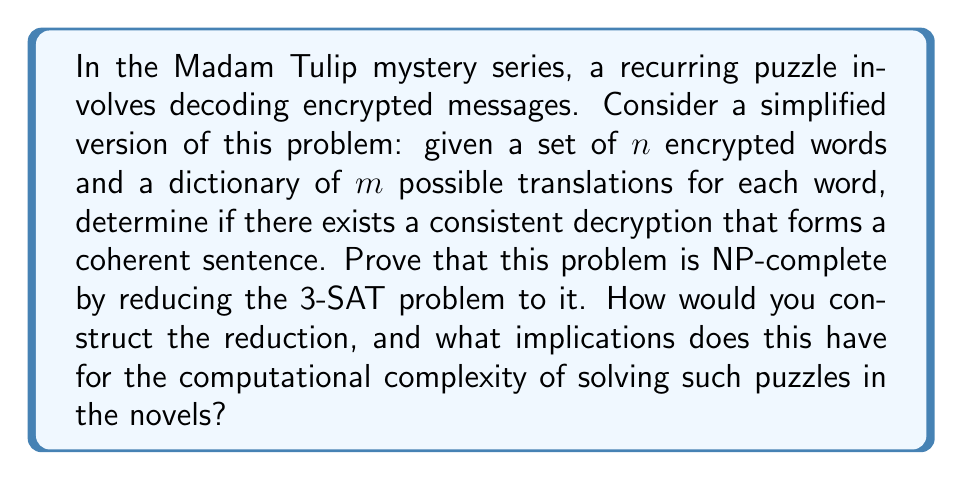What is the answer to this math problem? To prove that the simplified decryption problem is NP-complete, we need to show that it is in NP and that it is NP-hard. We'll focus on the NP-hardness proof by reducing 3-SAT to our problem.

1. Problem formulation:
   - Input: $n$ encrypted words, each with $m$ possible translations
   - Output: YES if there exists a consistent decryption forming a coherent sentence, NO otherwise

2. 3-SAT problem:
   - Input: A boolean formula in conjunctive normal form with 3 literals per clause
   - Output: YES if there exists a satisfying assignment, NO otherwise

3. Reduction from 3-SAT to the decryption problem:
   a. For each variable $x_i$ in the 3-SAT formula, create an encrypted word $w_i$ with two possible translations: "TRUE" and "FALSE"
   b. For each clause $(l_1 \vee l_2 \vee l_3)$, create an encrypted word $c_j$ with 7 possible translations:
      - "T1T2T3", "T1T2F3", "T1F2T3", "F1T2T3", "T1F2F3", "F1T2F3", "F1F2T3"
      (where T represents TRUE and F represents FALSE)
   c. Add two additional encrypted words: "BEGIN" and "END" with only one translation each

4. Construct the sentence structure:
   $$\text{BEGIN } w_1 \ldots w_n c_1 \ldots c_m \text{ END}$$

5. Proving equivalence:
   - If the 3-SAT formula is satisfiable, there exists a consistent decryption:
     * Translate $w_i$ according to the satisfying assignment
     * Choose the appropriate translation for each $c_j$ based on the satisfying literals
   - If there exists a consistent decryption, the 3-SAT formula is satisfiable:
     * The translations of $w_i$ provide a satisfying assignment
     * The translations of $c_j$ ensure all clauses are satisfied

6. Complexity analysis:
   - The reduction is polynomial-time: $O(n + m)$ where $n$ is the number of variables and $m$ is the number of clauses
   - The decryption problem is in NP: a non-deterministic algorithm can guess a decryption and verify it in polynomial time

Therefore, the simplified decryption problem is NP-complete. This implies that solving such puzzles in the Madam Tulip novels is computationally intractable for large instances, assuming P ≠ NP. In practice, this means that as the complexity of the encrypted messages increases, the time required to solve them grows exponentially, making it challenging for both the characters and readers to solve very large instances of these puzzles efficiently.
Answer: The simplified decryption problem in the Madam Tulip series is NP-complete. The reduction from 3-SAT demonstrates that solving these puzzles is computationally intractable for large instances, assuming P ≠ NP. This implies that the difficulty of solving such puzzles in the novels increases exponentially with the size and complexity of the encrypted messages. 